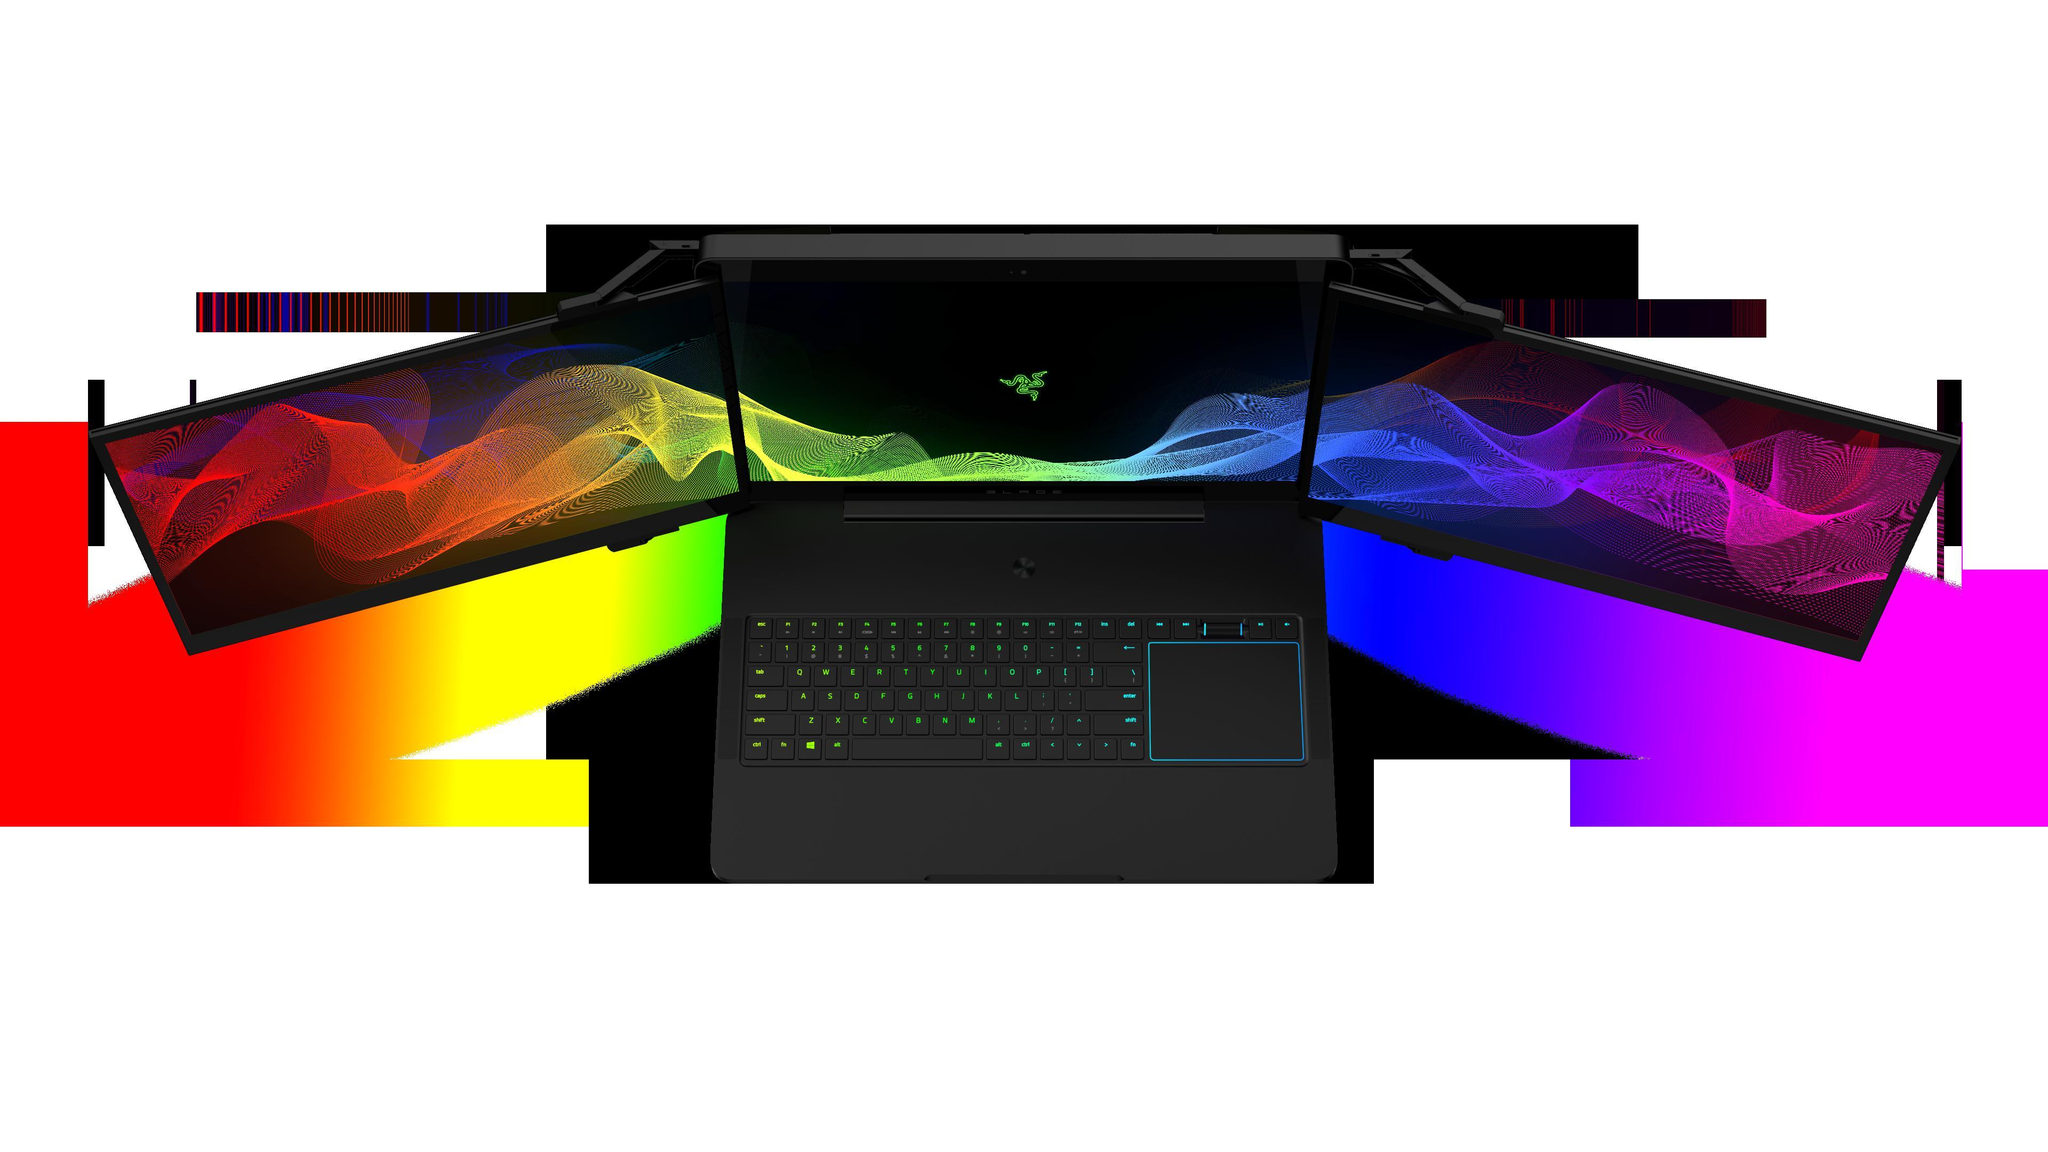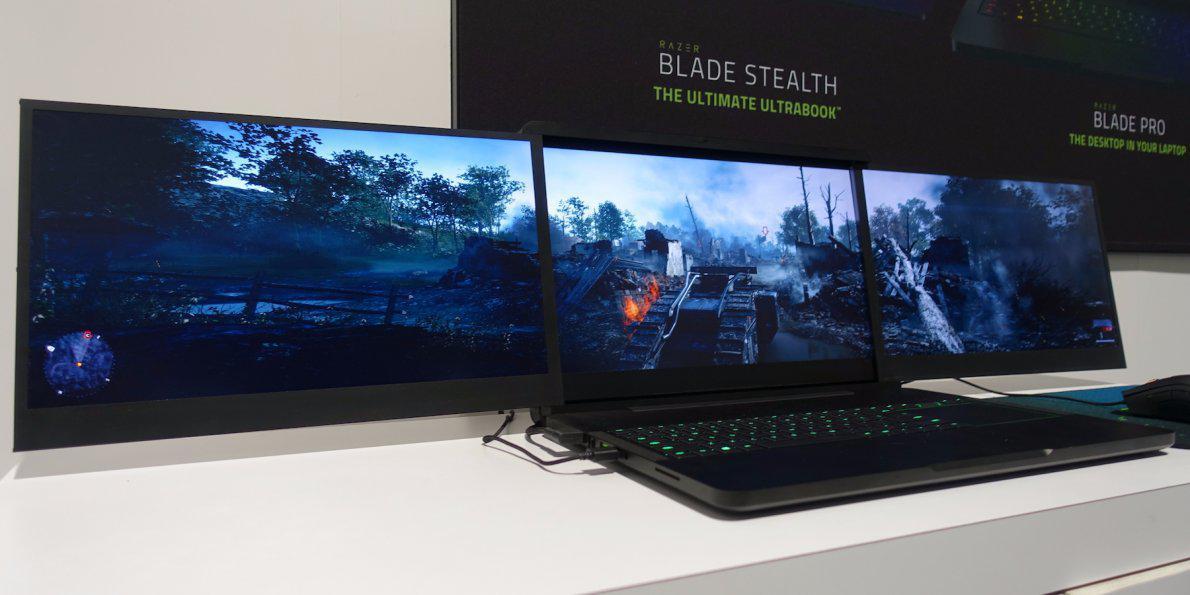The first image is the image on the left, the second image is the image on the right. Evaluate the accuracy of this statement regarding the images: "An image shows a back-to-front row of three keyboards with opened screens displaying various bright colors.". Is it true? Answer yes or no. No. The first image is the image on the left, the second image is the image on the right. Examine the images to the left and right. Is the description "One laptop is opened up in one of the images." accurate? Answer yes or no. No. 